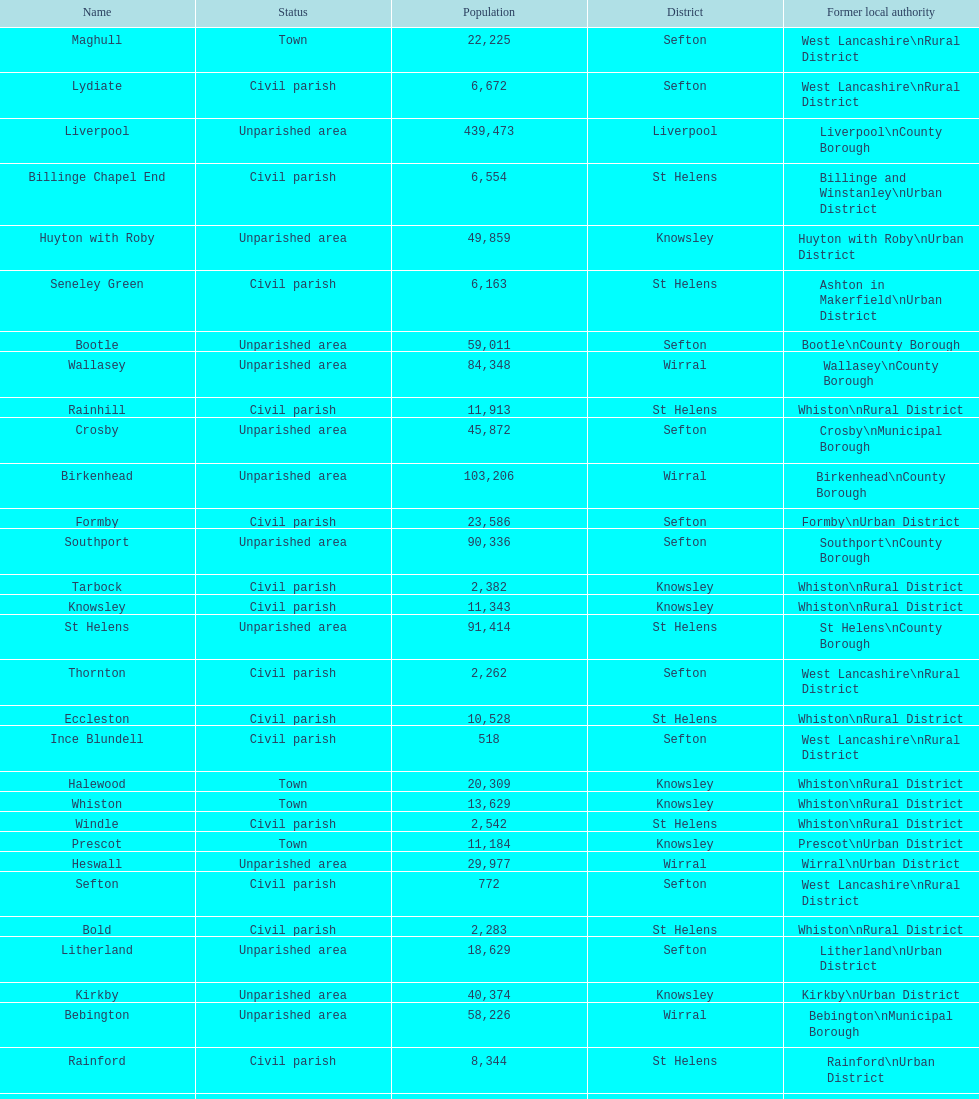How many people live in the bold civil parish? 2,283. 